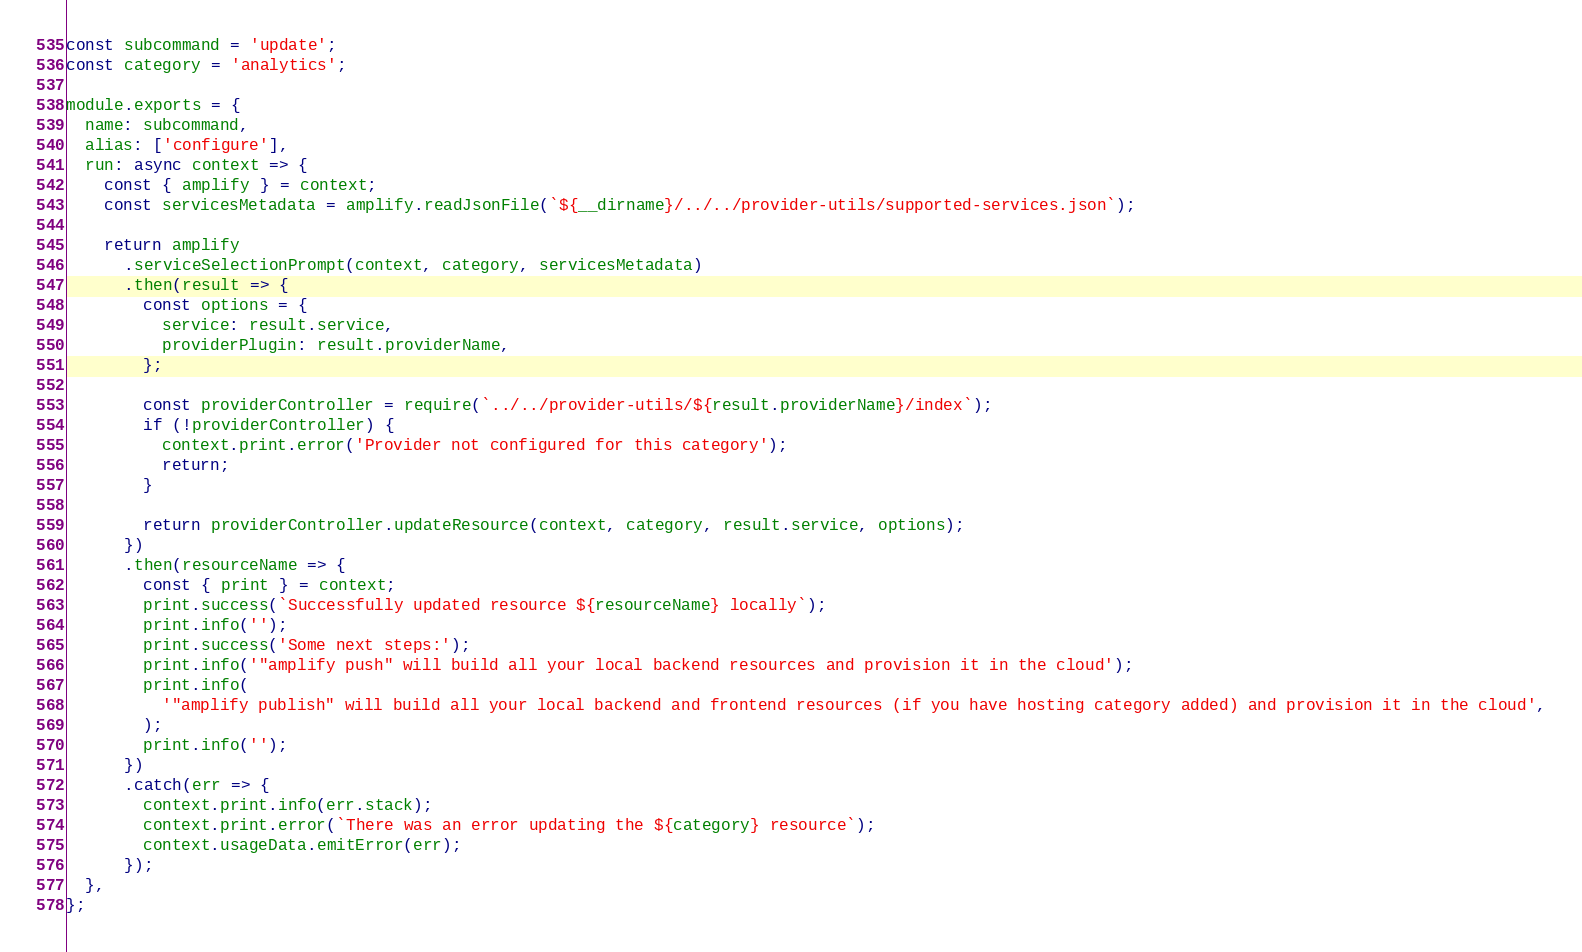<code> <loc_0><loc_0><loc_500><loc_500><_JavaScript_>const subcommand = 'update';
const category = 'analytics';

module.exports = {
  name: subcommand,
  alias: ['configure'],
  run: async context => {
    const { amplify } = context;
    const servicesMetadata = amplify.readJsonFile(`${__dirname}/../../provider-utils/supported-services.json`);

    return amplify
      .serviceSelectionPrompt(context, category, servicesMetadata)
      .then(result => {
        const options = {
          service: result.service,
          providerPlugin: result.providerName,
        };

        const providerController = require(`../../provider-utils/${result.providerName}/index`);
        if (!providerController) {
          context.print.error('Provider not configured for this category');
          return;
        }

        return providerController.updateResource(context, category, result.service, options);
      })
      .then(resourceName => {
        const { print } = context;
        print.success(`Successfully updated resource ${resourceName} locally`);
        print.info('');
        print.success('Some next steps:');
        print.info('"amplify push" will build all your local backend resources and provision it in the cloud');
        print.info(
          '"amplify publish" will build all your local backend and frontend resources (if you have hosting category added) and provision it in the cloud',
        );
        print.info('');
      })
      .catch(err => {
        context.print.info(err.stack);
        context.print.error(`There was an error updating the ${category} resource`);
        context.usageData.emitError(err);
      });
  },
};
</code> 